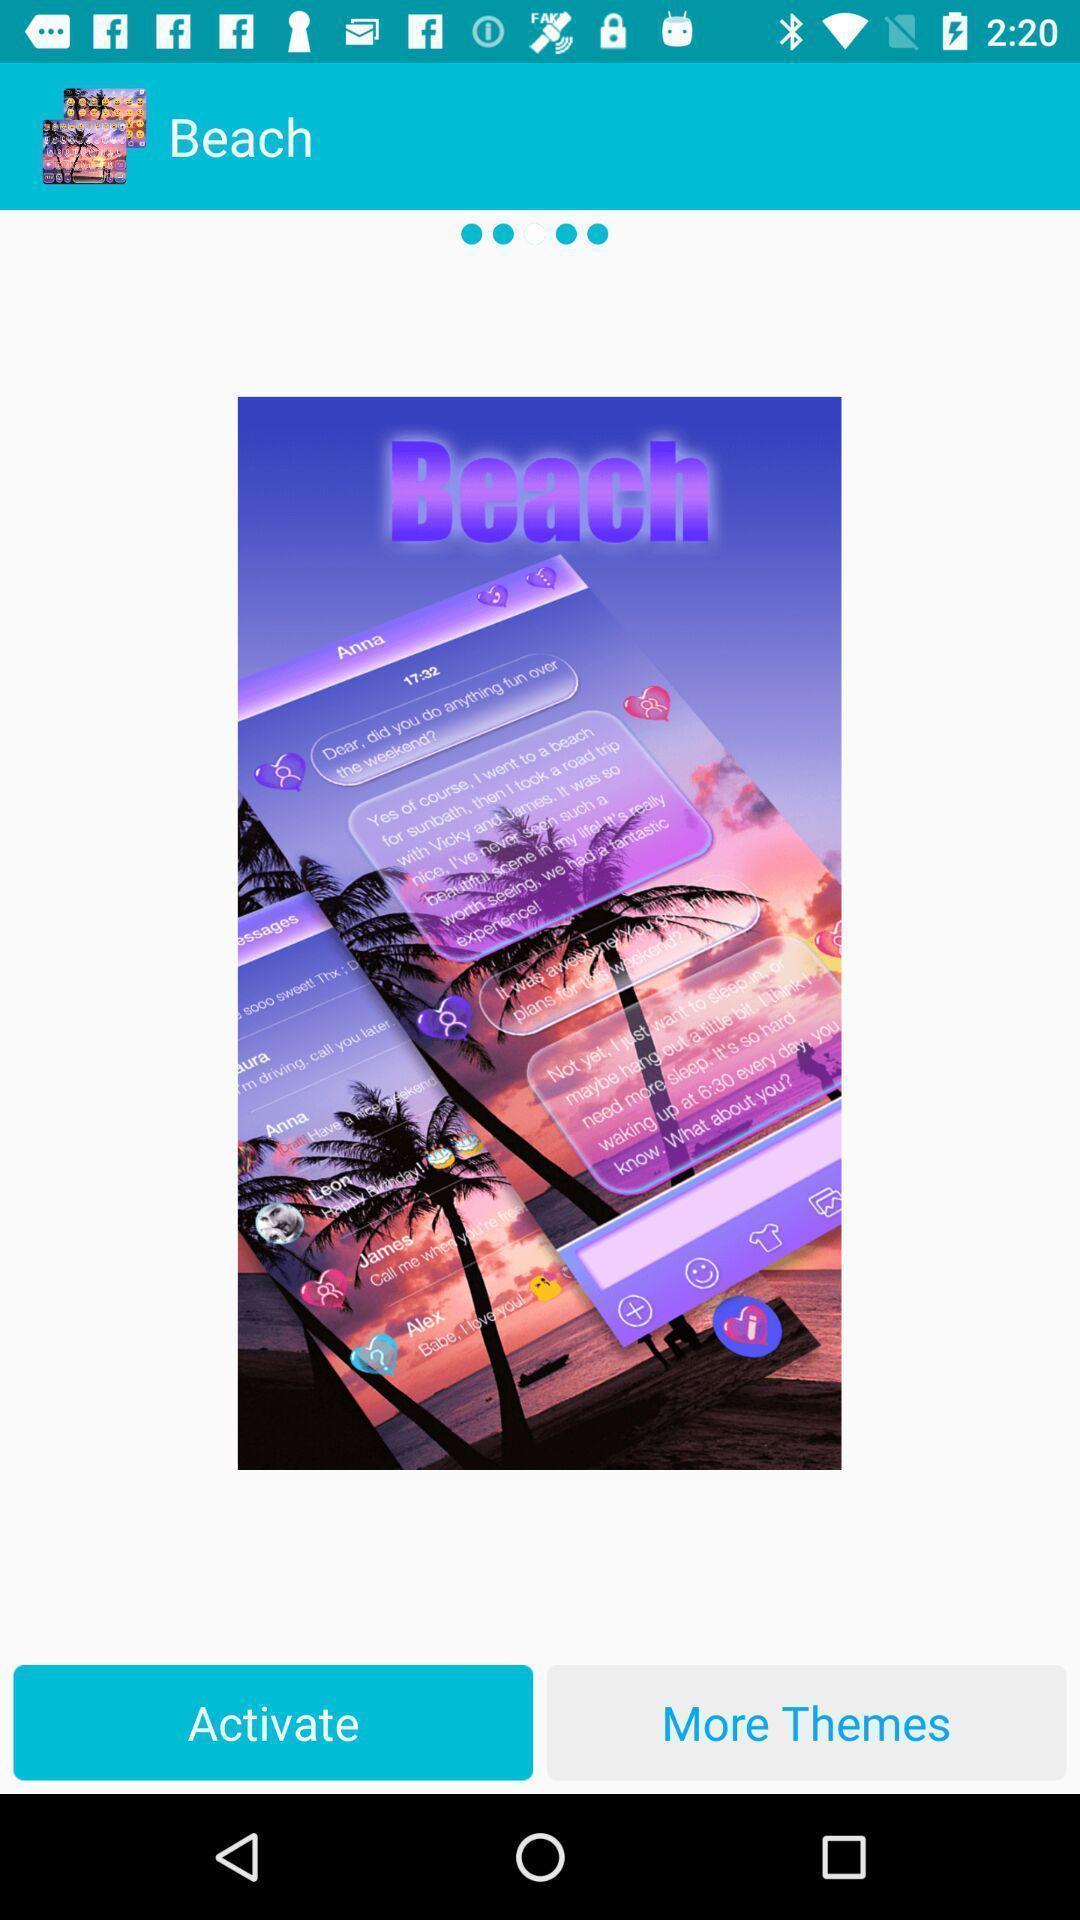Tell me about the visual elements in this screen capture. Screen displaying multiple setting options in a theme page. 